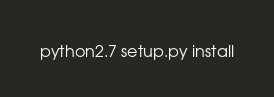<code> <loc_0><loc_0><loc_500><loc_500><_Bash_>python2.7 setup.py install
</code> 